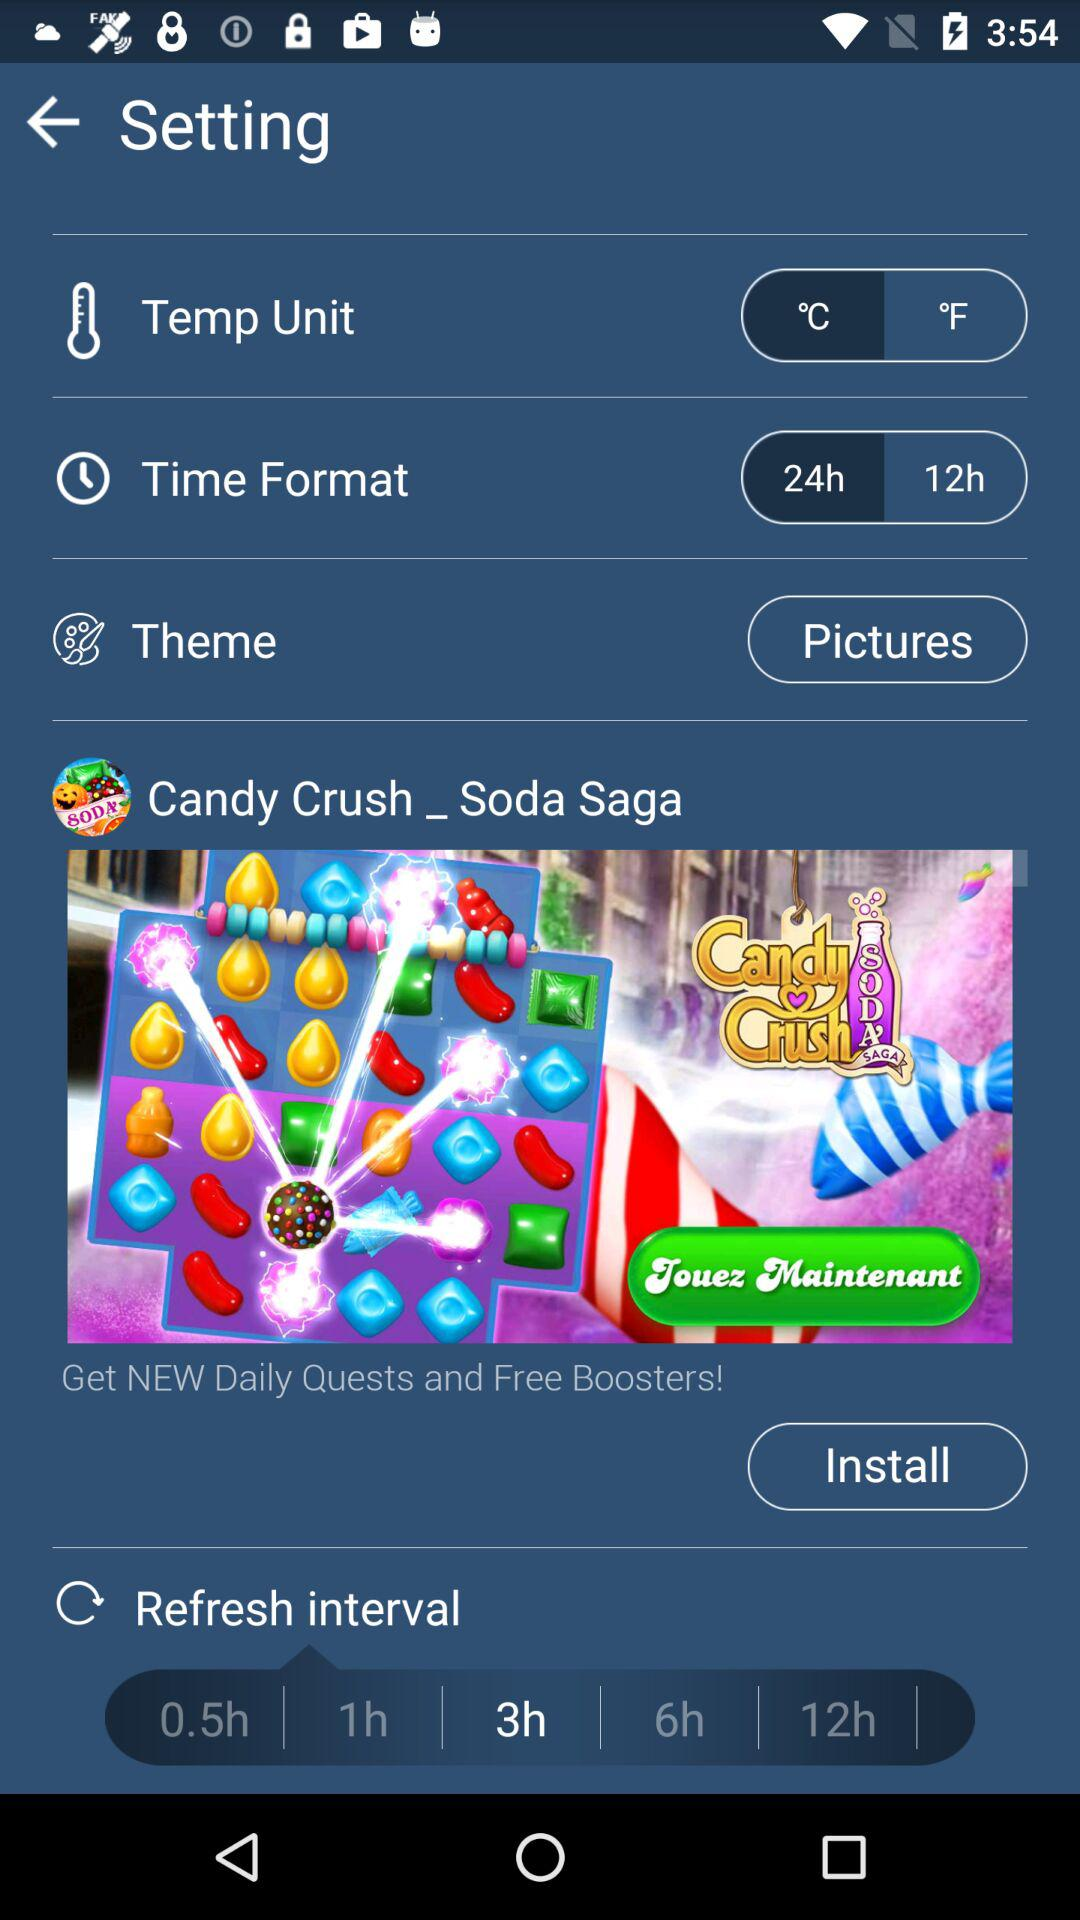What is the selected temperature unit? The selected temperature unit is °F. 